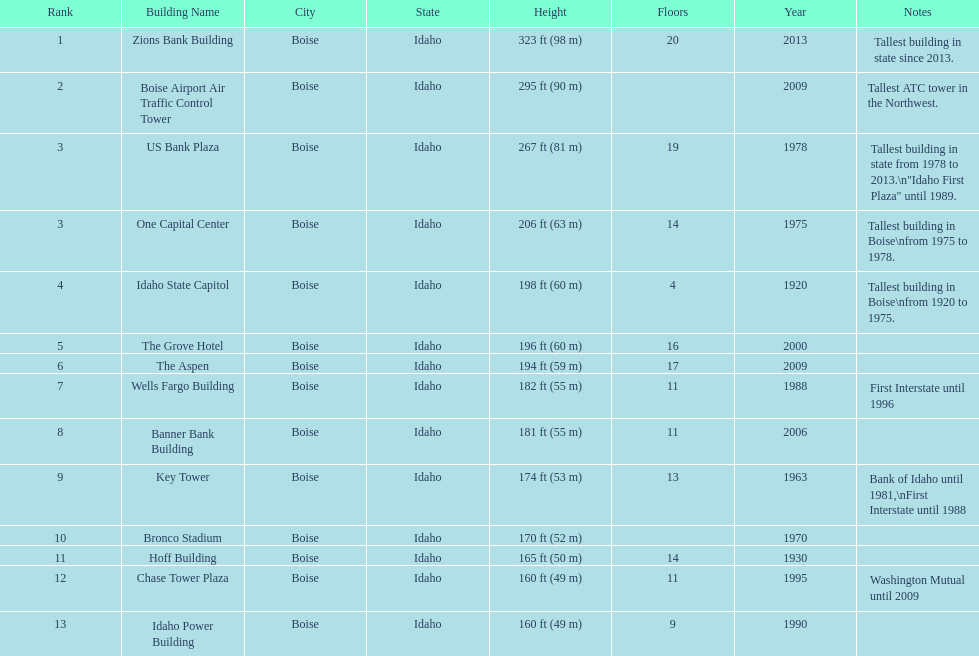How many floors does the tallest building have? 20. 